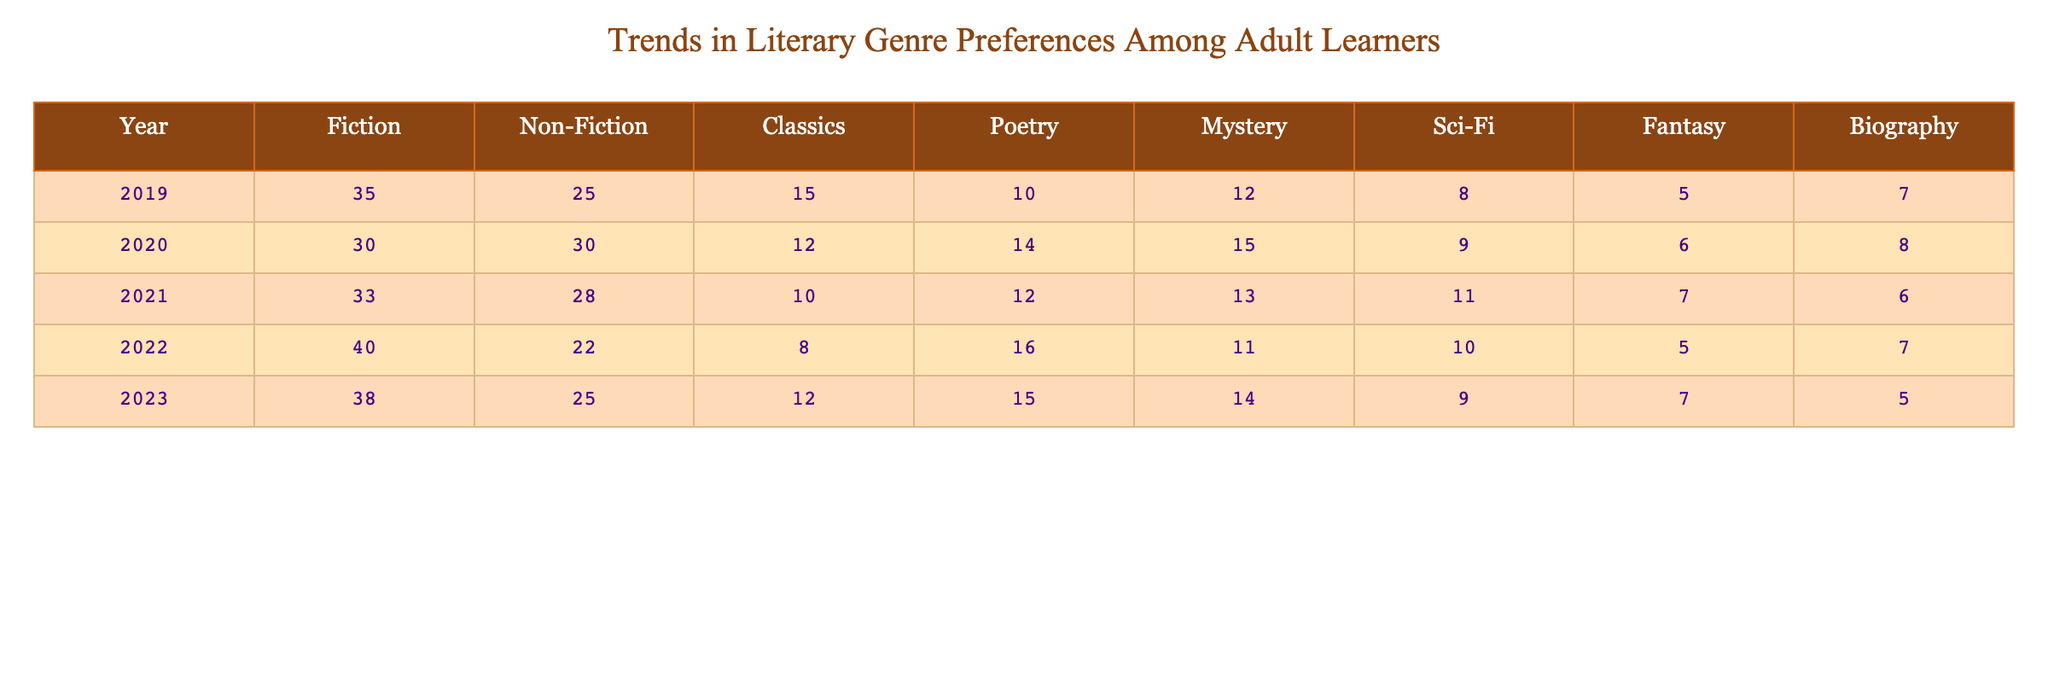What was the percentage of Fiction readers in 2020? In 2020, Fiction readers made up 30 out of a total of 100 participants (sum of all genres for that year: 30 + 30 + 12 + 14 + 15 + 9 + 6 + 8 = 124). So, the percentage is (30/124)*100 ≈ 24.19%.
Answer: 24.19% In which year did the preference for Non-Fiction peak? The highest value for Non-Fiction is 30, which occurred in 2020.
Answer: 2020 What is the total number of readers for Poetry over the five years? Adding the values for Poetry from each year: 10 + 14 + 12 + 16 + 15 = 67.
Answer: 67 Did the preference for Classics increase from 2019 to 2023? The value for Classics decreased from 15 in 2019 to 12 in 2023, indicating a decline.
Answer: No Which genre had the largest decrease in preference from 2019 to 2022? Fiction decreased from 35 in 2019 to 40 in 2022 (a gain), while Classics decreased from 15 to 8, making it the largest decrease.
Answer: Classics What was the average preference for Mystery over the five years? Adding the Mystery values gives 12 + 15 + 13 + 11 + 14 = 65. The average is 65/5 = 13.
Answer: 13 Were there any years where the preference for Sci-Fi was higher than Fantasy? In 2019, 2020, and 2021, Sci-Fi was higher than Fantasy, but not in 2022 and 2023.
Answer: Yes What is the total increase in Fiction readers from 2019 to 2021? Fiction went from 35 in 2019 to 33 in 2021, indicating a decrease of 2.
Answer: -2 In 2023, how did the preference for Biography compare to Poetry? In 2023, the preference for Biography was 5 while Poetry had a preference of 15, indicating Poetry was more preferred.
Answer: Poetry was more preferred Which genre consistently maintained its popularity over the five years? Non-Fiction remained relatively stable, having the second highest preference each year and fluctuating only slightly.
Answer: Non-Fiction What was the overall trend in genre preferences across five years? An analysis shows that Fiction and Non-Fiction remained popular, while Classics and Biography generally declined.
Answer: Decline in Classics and Biography; stability in Fiction and Non-Fiction 